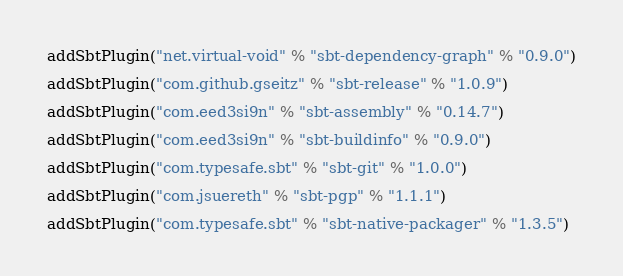Convert code to text. <code><loc_0><loc_0><loc_500><loc_500><_Scala_>addSbtPlugin("net.virtual-void" % "sbt-dependency-graph" % "0.9.0")

addSbtPlugin("com.github.gseitz" % "sbt-release" % "1.0.9")

addSbtPlugin("com.eed3si9n" % "sbt-assembly" % "0.14.7")

addSbtPlugin("com.eed3si9n" % "sbt-buildinfo" % "0.9.0")

addSbtPlugin("com.typesafe.sbt" % "sbt-git" % "1.0.0")

addSbtPlugin("com.jsuereth" % "sbt-pgp" % "1.1.1")

addSbtPlugin("com.typesafe.sbt" % "sbt-native-packager" % "1.3.5")
</code> 